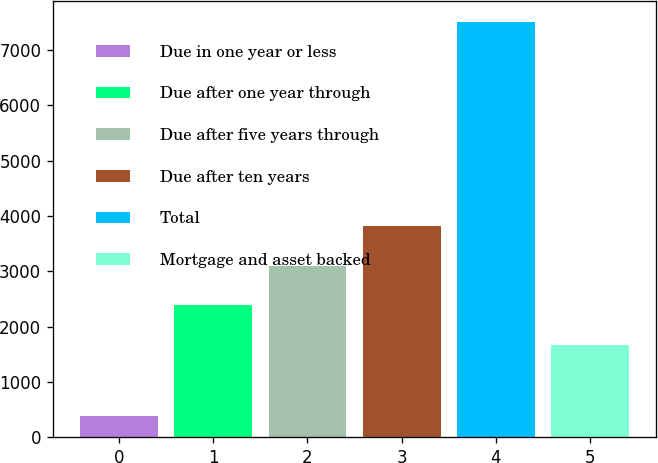Convert chart. <chart><loc_0><loc_0><loc_500><loc_500><bar_chart><fcel>Due in one year or less<fcel>Due after one year through<fcel>Due after five years through<fcel>Due after ten years<fcel>Total<fcel>Mortgage and asset backed<nl><fcel>391<fcel>2388<fcel>3099<fcel>3810<fcel>7501<fcel>1677<nl></chart> 